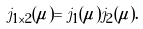<formula> <loc_0><loc_0><loc_500><loc_500>j _ { 1 \times 2 } ( \mu ) = j _ { 1 } ( \mu ) j _ { 2 } ( \mu ) .</formula> 